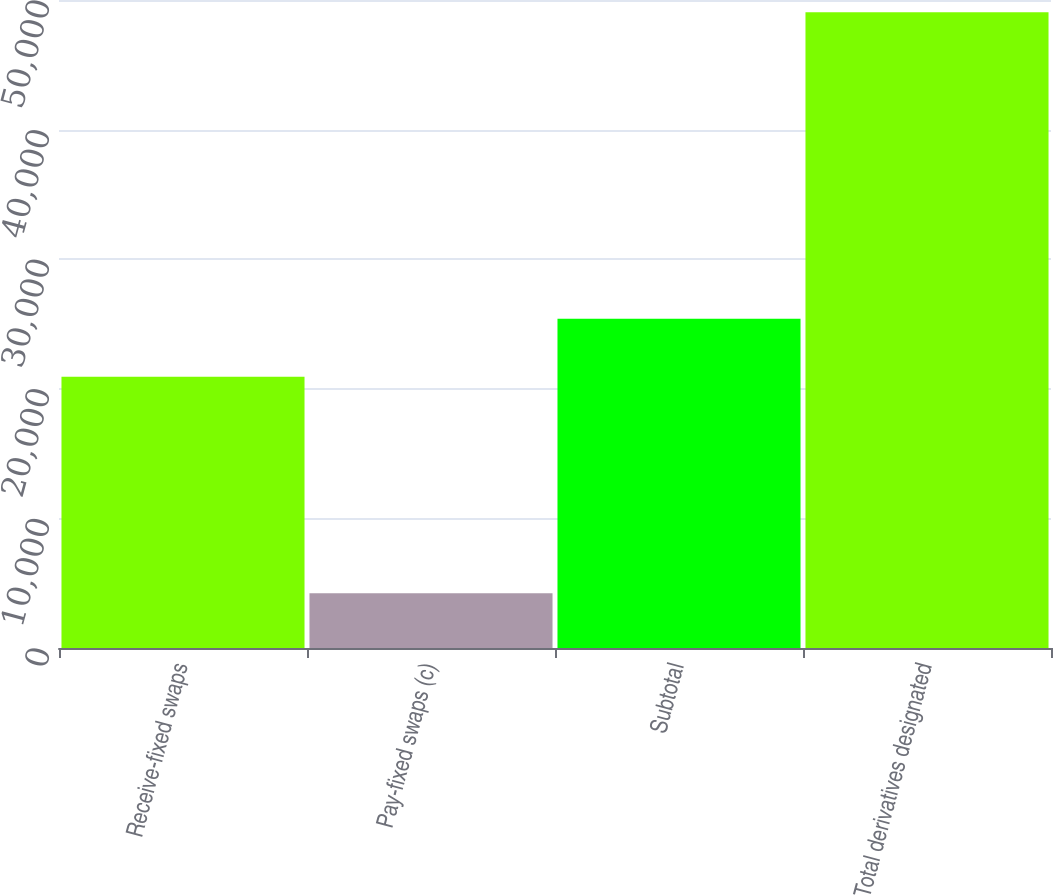<chart> <loc_0><loc_0><loc_500><loc_500><bar_chart><fcel>Receive-fixed swaps<fcel>Pay-fixed swaps (c)<fcel>Subtotal<fcel>Total derivatives designated<nl><fcel>20930<fcel>4233<fcel>25412.8<fcel>49061<nl></chart> 